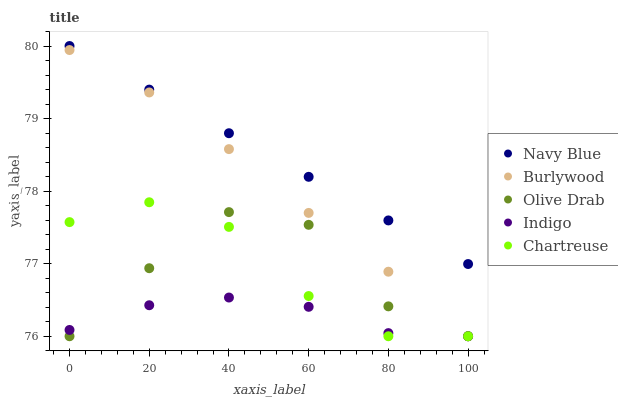Does Indigo have the minimum area under the curve?
Answer yes or no. Yes. Does Navy Blue have the maximum area under the curve?
Answer yes or no. Yes. Does Chartreuse have the minimum area under the curve?
Answer yes or no. No. Does Chartreuse have the maximum area under the curve?
Answer yes or no. No. Is Navy Blue the smoothest?
Answer yes or no. Yes. Is Olive Drab the roughest?
Answer yes or no. Yes. Is Chartreuse the smoothest?
Answer yes or no. No. Is Chartreuse the roughest?
Answer yes or no. No. Does Burlywood have the lowest value?
Answer yes or no. Yes. Does Navy Blue have the lowest value?
Answer yes or no. No. Does Navy Blue have the highest value?
Answer yes or no. Yes. Does Chartreuse have the highest value?
Answer yes or no. No. Is Burlywood less than Navy Blue?
Answer yes or no. Yes. Is Navy Blue greater than Olive Drab?
Answer yes or no. Yes. Does Chartreuse intersect Olive Drab?
Answer yes or no. Yes. Is Chartreuse less than Olive Drab?
Answer yes or no. No. Is Chartreuse greater than Olive Drab?
Answer yes or no. No. Does Burlywood intersect Navy Blue?
Answer yes or no. No. 